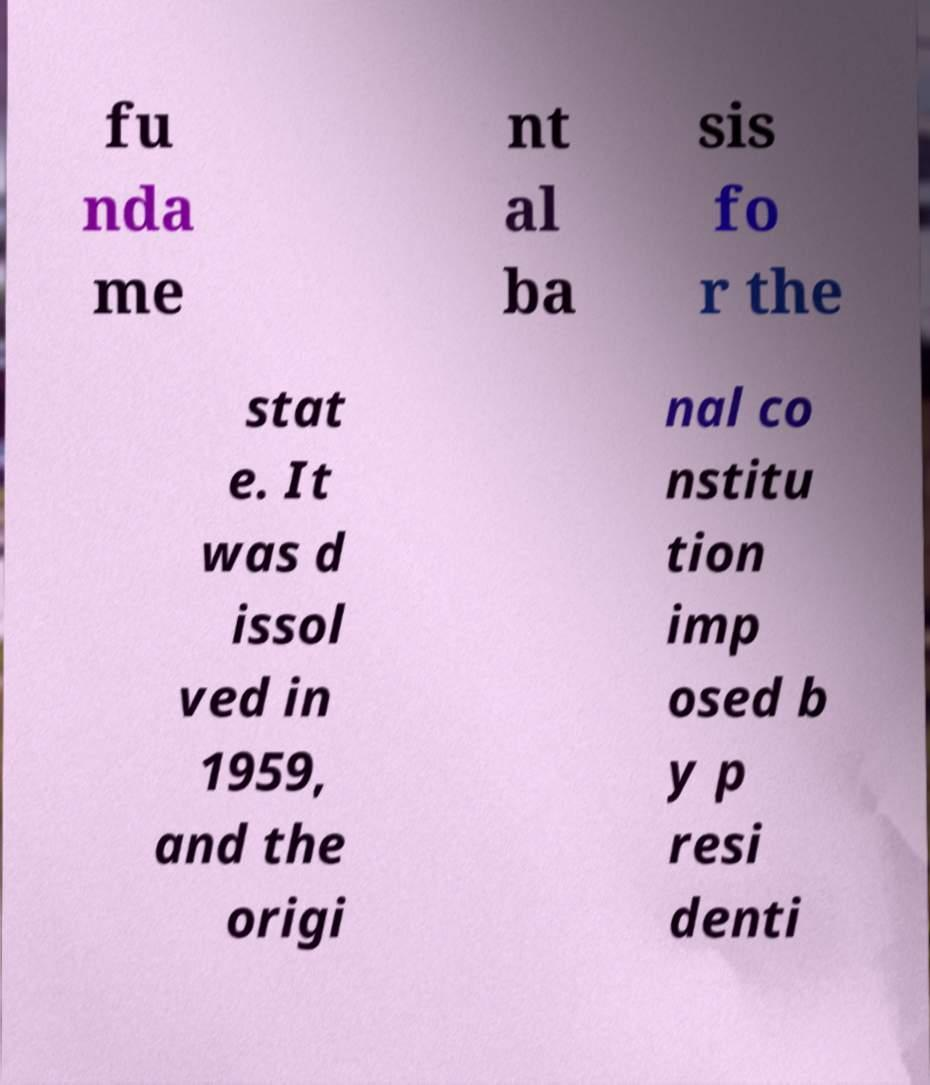For documentation purposes, I need the text within this image transcribed. Could you provide that? fu nda me nt al ba sis fo r the stat e. It was d issol ved in 1959, and the origi nal co nstitu tion imp osed b y p resi denti 